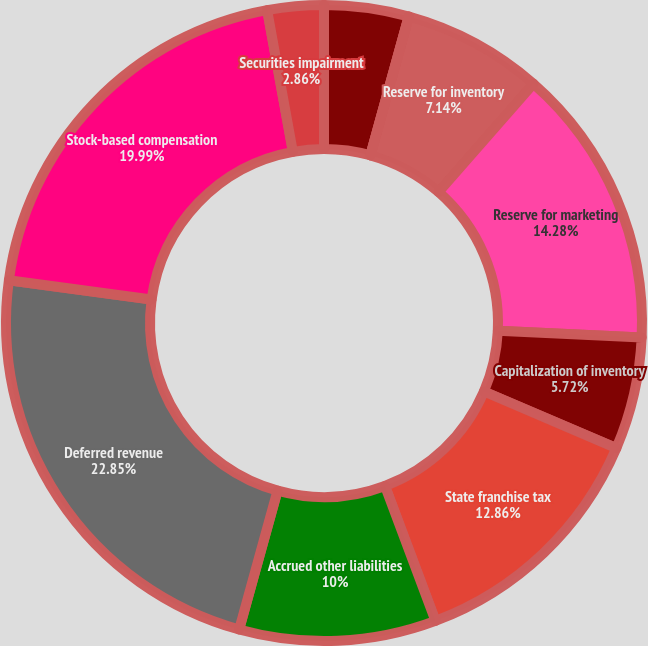Convert chart to OTSL. <chart><loc_0><loc_0><loc_500><loc_500><pie_chart><fcel>Reserve for sales returns<fcel>Reserve for doubtful accounts<fcel>Reserve for inventory<fcel>Reserve for marketing<fcel>Capitalization of inventory<fcel>State franchise tax<fcel>Accrued other liabilities<fcel>Deferred revenue<fcel>Stock-based compensation<fcel>Securities impairment<nl><fcel>4.29%<fcel>0.01%<fcel>7.14%<fcel>14.28%<fcel>5.72%<fcel>12.86%<fcel>10.0%<fcel>22.85%<fcel>19.99%<fcel>2.86%<nl></chart> 